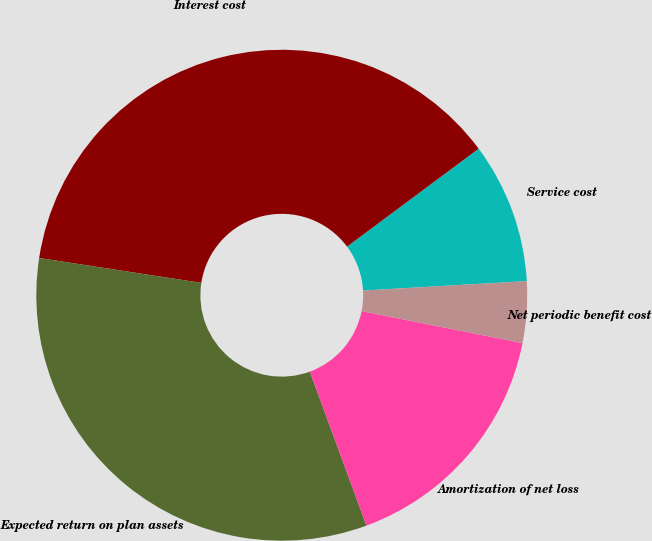<chart> <loc_0><loc_0><loc_500><loc_500><pie_chart><fcel>Service cost<fcel>Interest cost<fcel>Expected return on plan assets<fcel>Amortization of net loss<fcel>Net periodic benefit cost<nl><fcel>9.27%<fcel>37.39%<fcel>33.03%<fcel>16.27%<fcel>4.04%<nl></chart> 